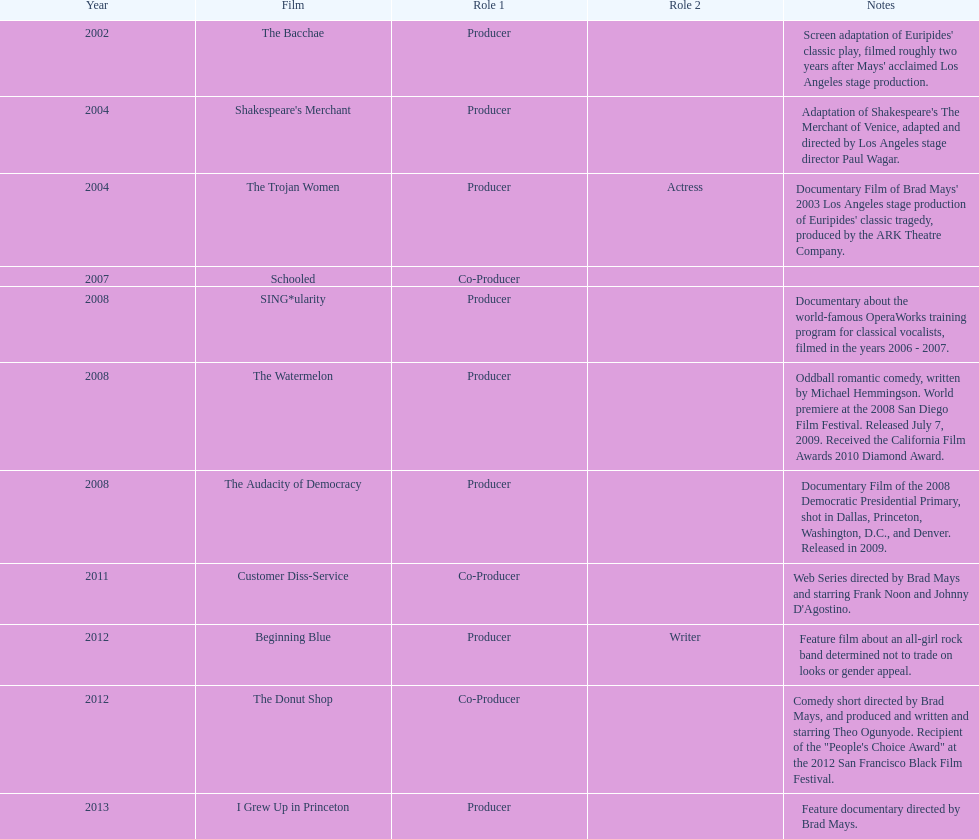What documentary film was produced before the year 2011 but after 2008? The Audacity of Democracy. 